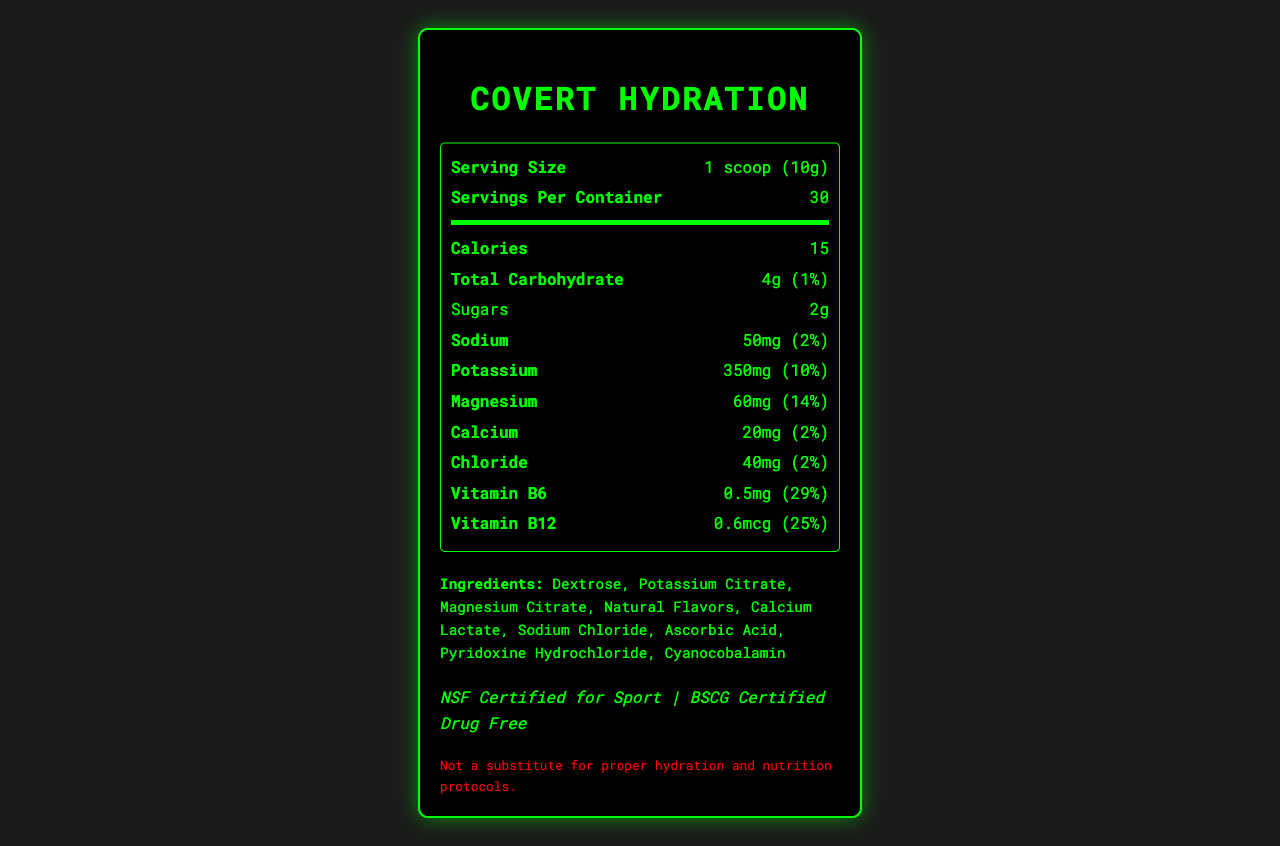what is the serving size? The document directly mentions that the serving size is 1 scoop (10g).
Answer: 1 scoop (10g) how many servings are in one container? The document specifies that there are 30 servings per container.
Answer: 30 what is the calorie count per serving? The document states that there are 15 calories per serving.
Answer: 15 what is the amount of sodium per serving? According to the document, each serving contains 50mg of sodium.
Answer: 50mg what is the amount of potassium per serving? The document shows that each serving has 350mg of potassium.
Answer: 350mg which ingredient is not in Covert Hydration? A. Dextrose B. Aspartame C. Sodium Chloride D. Magnesium Citrate The document lists the ingredients and Aspartame is not included.
Answer: B what is the percent Daily Value (%DV) for Vitamin B12? A. 10% B. 25% C. 30% D. 40% The %DV for Vitamin B12 is listed as 25% in the document.
Answer: B does Covert Hydration contain any allergens? The document states it is manufactured in a facility that also processes soy and milk products.
Answer: Yes is Covert Hydration suitable for general consumer use? The document mentions that the product is intended for use by trained professionals in high-stress environments and may not be suitable for general consumer use.
Answer: No summarize the key information provided in the document. The summary captures the main features of Covert Hydration, its nutritional content, certifications, packaging, and allergen information.
Answer: Covert Hydration is a low-sodium, high-potassium electrolyte powder designed for extended field operations. It contains 15 calories, 50mg of sodium, 350mg of potassium, and other essential minerals and vitamins per serving. The product is NSF Certified for Sport and BSCG Certified Drug Free. It is packaged in environmentally friendly, non-reflective, sound-dampening pouches, with a shelf life of 5 years. Ingredients include Dextrose, Potassium Citrate, and Magnesium Citrate, among others. what is the primary purpose of Covert Hydration's packaging? The document highlights that the packaging is designed to be non-reflective and sound-dampening for use in sensitive, covert environments.
Answer: Stealth operations how many grams of sugars are in each serving? The document specifies that there are 2 grams of sugars per serving.
Answer: 2g what is the proportion of carbohydrates per serving? The %DV for total carbohydrates per serving is listed as 1%.
Answer: 1% how long is the shelf life of Covert Hydration when stored properly? The document states that the shelf life is 5 years when stored in cool, dry conditions.
Answer: 5 years which certification is not mentioned for Covert Hydration? A. Certified Vegan B. NSF Certified for Sport C. BSCG Certified Drug Free The document mentions NSF Certified for Sport and BSCG Certified Drug Free, but not Certified Vegan.
Answer: A what is the percent Daily Value (%DV) for magnesium? The %DV for magnesium is 14% as given in the document.
Answer: 14% is Covert Hydration a substitute for proper hydration and nutrition? The document clearly states that it is not a substitute for proper hydration and nutrition protocols.
Answer: No what are some potential medical concerns mentioned before using this product? The document advises consulting with a healthcare professional if you have kidney problems or are on a potassium-restricted diet.
Answer: Kidney problems or potassium-restricted diet what antioxidants are present in Covert Hydration? The document does not provide information regarding antioxidants in Covert Hydration.
Answer: Not enough information 